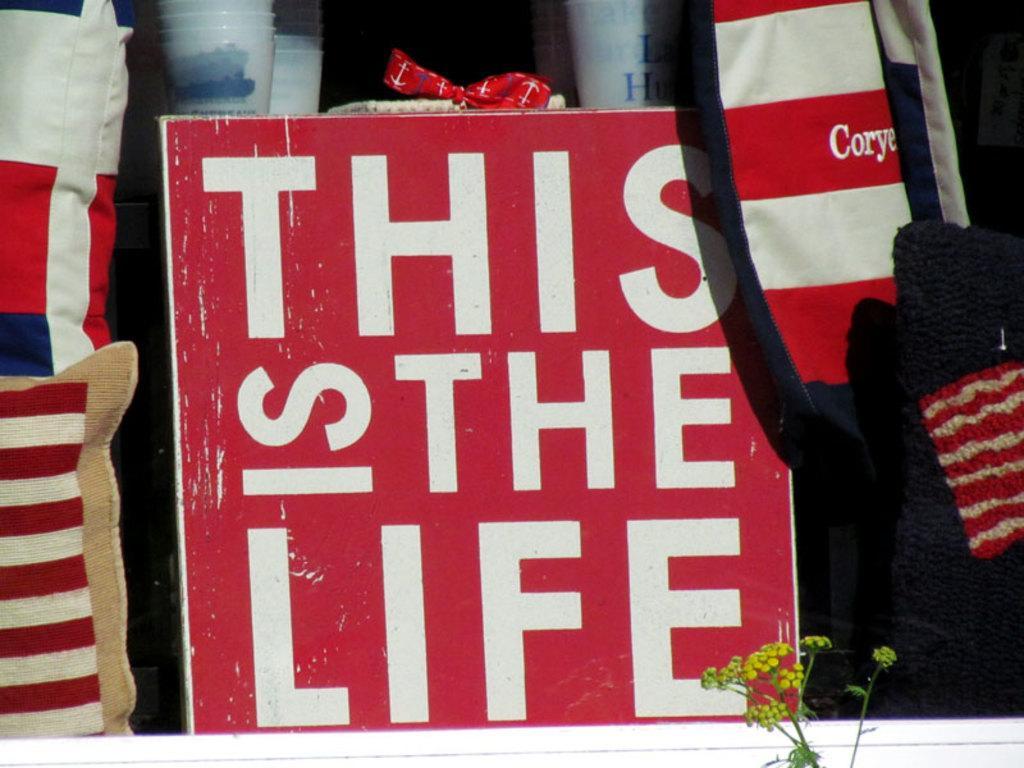Could you give a brief overview of what you see in this image? In this image we can see many objects. We can see some text on the board. There is a plant at the bottom of the image. 